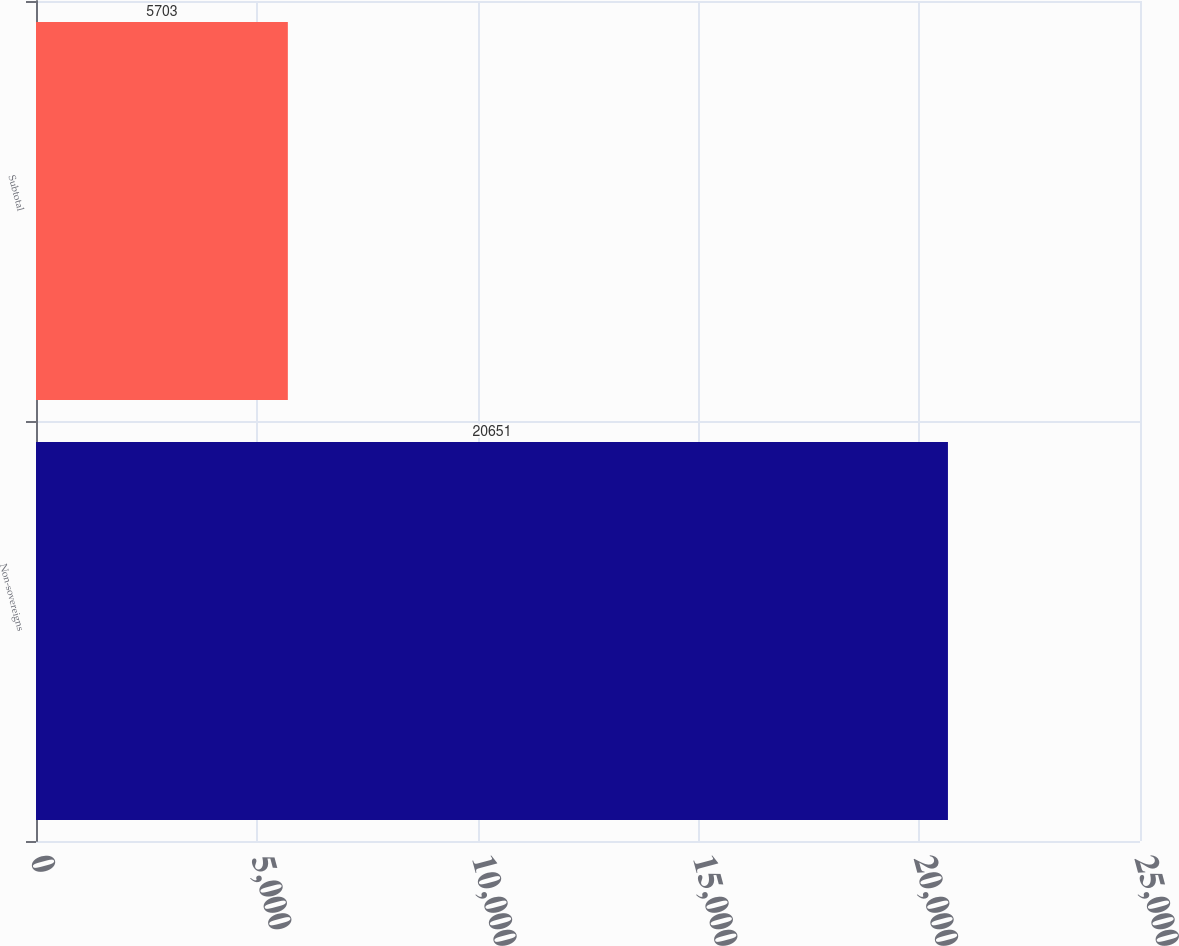Convert chart. <chart><loc_0><loc_0><loc_500><loc_500><bar_chart><fcel>Non-sovereigns<fcel>Subtotal<nl><fcel>20651<fcel>5703<nl></chart> 